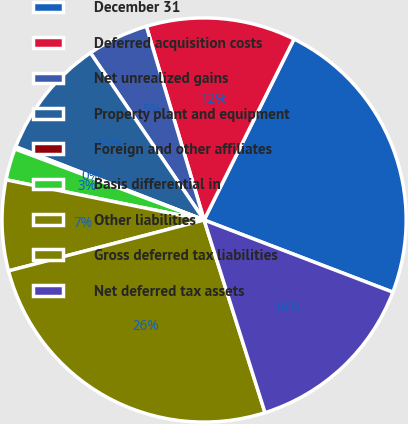Convert chart. <chart><loc_0><loc_0><loc_500><loc_500><pie_chart><fcel>December 31<fcel>Deferred acquisition costs<fcel>Net unrealized gains<fcel>Property plant and equipment<fcel>Foreign and other affiliates<fcel>Basis differential in<fcel>Other liabilities<fcel>Gross deferred tax liabilities<fcel>Net deferred tax assets<nl><fcel>23.47%<fcel>11.95%<fcel>4.89%<fcel>9.6%<fcel>0.18%<fcel>2.53%<fcel>7.24%<fcel>25.82%<fcel>14.31%<nl></chart> 